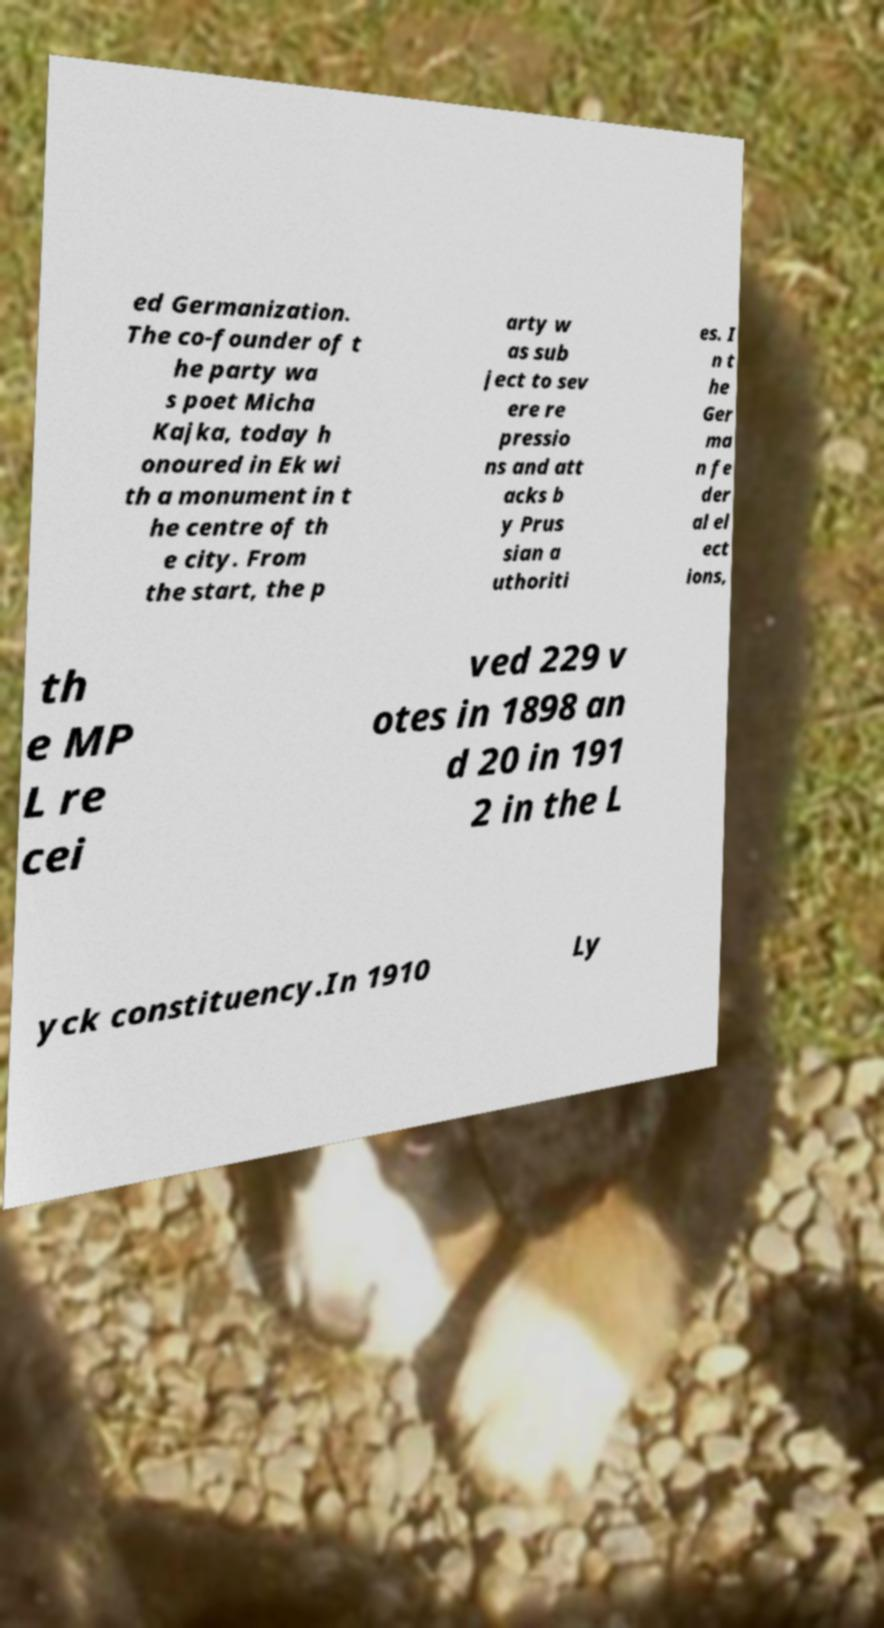Can you read and provide the text displayed in the image?This photo seems to have some interesting text. Can you extract and type it out for me? ed Germanization. The co-founder of t he party wa s poet Micha Kajka, today h onoured in Ek wi th a monument in t he centre of th e city. From the start, the p arty w as sub ject to sev ere re pressio ns and att acks b y Prus sian a uthoriti es. I n t he Ger ma n fe der al el ect ions, th e MP L re cei ved 229 v otes in 1898 an d 20 in 191 2 in the L yck constituency.In 1910 Ly 